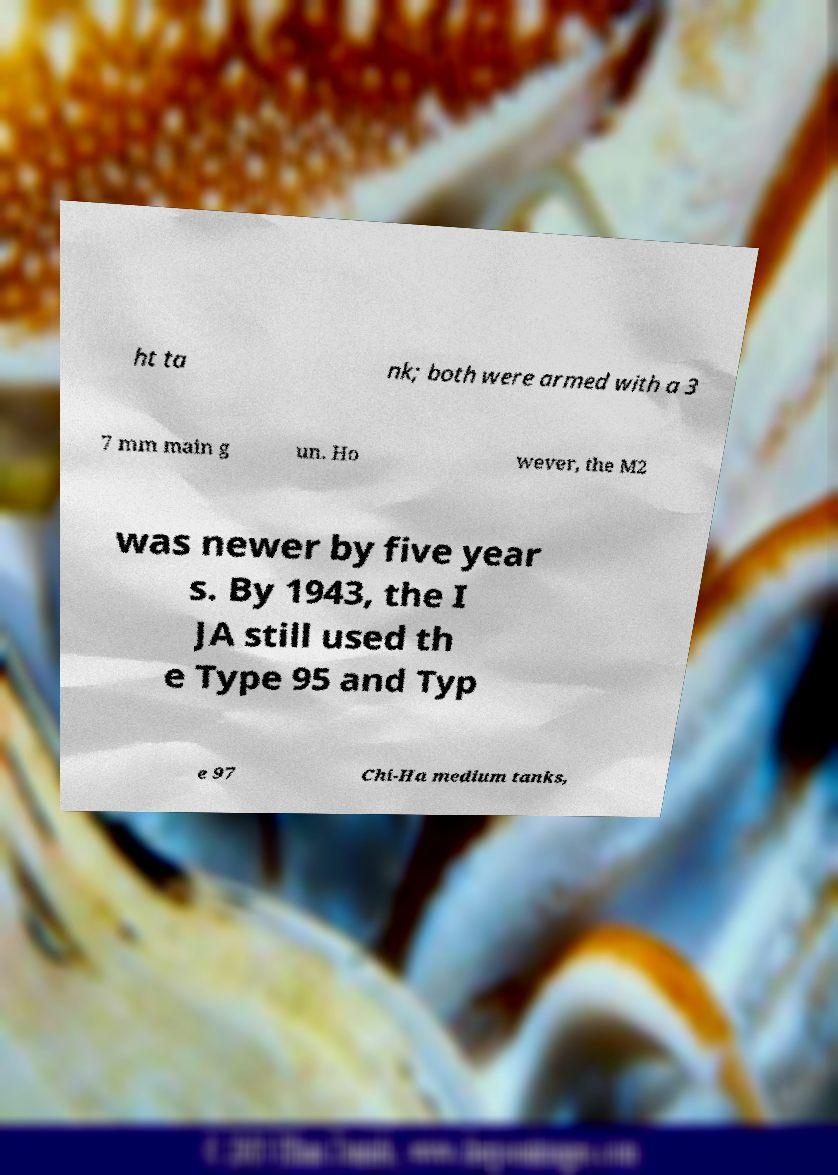Can you read and provide the text displayed in the image?This photo seems to have some interesting text. Can you extract and type it out for me? ht ta nk; both were armed with a 3 7 mm main g un. Ho wever, the M2 was newer by five year s. By 1943, the I JA still used th e Type 95 and Typ e 97 Chi-Ha medium tanks, 